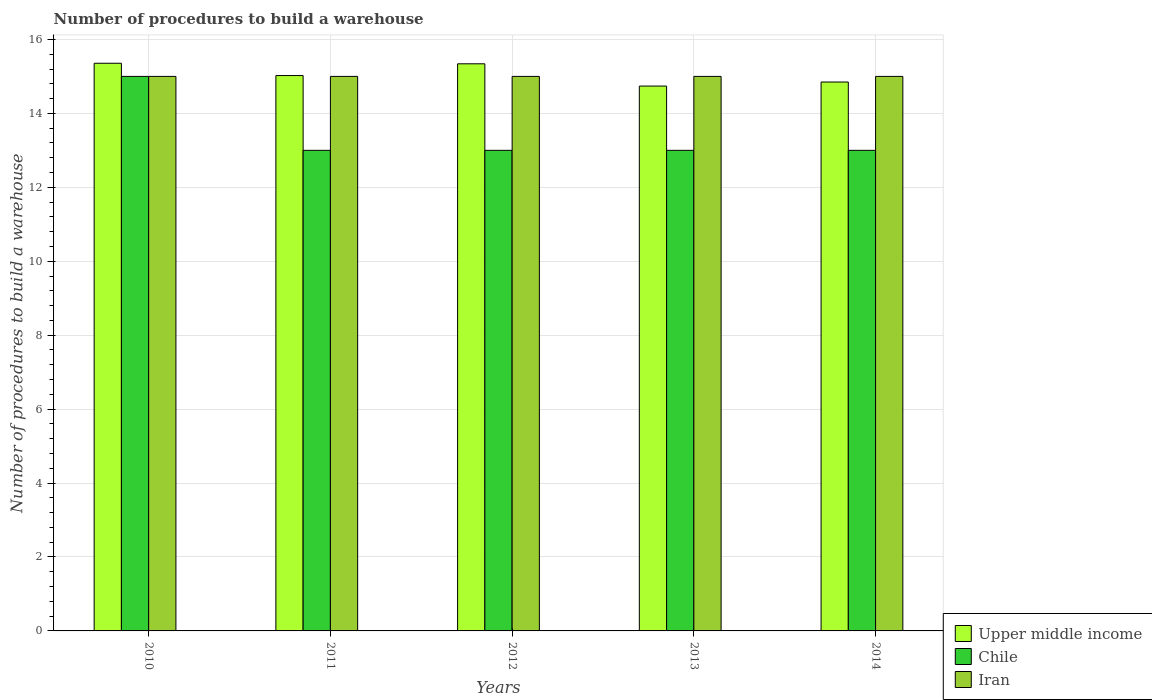How many different coloured bars are there?
Your response must be concise. 3. How many groups of bars are there?
Provide a short and direct response. 5. Are the number of bars per tick equal to the number of legend labels?
Your response must be concise. Yes. Are the number of bars on each tick of the X-axis equal?
Your response must be concise. Yes. How many bars are there on the 1st tick from the left?
Offer a terse response. 3. How many bars are there on the 3rd tick from the right?
Your answer should be compact. 3. In how many cases, is the number of bars for a given year not equal to the number of legend labels?
Provide a short and direct response. 0. What is the number of procedures to build a warehouse in in Iran in 2011?
Provide a succinct answer. 15. Across all years, what is the maximum number of procedures to build a warehouse in in Upper middle income?
Provide a succinct answer. 15.36. Across all years, what is the minimum number of procedures to build a warehouse in in Chile?
Your response must be concise. 13. In which year was the number of procedures to build a warehouse in in Upper middle income minimum?
Provide a succinct answer. 2013. What is the total number of procedures to build a warehouse in in Chile in the graph?
Give a very brief answer. 67. What is the difference between the number of procedures to build a warehouse in in Upper middle income in 2013 and that in 2014?
Offer a terse response. -0.11. What is the difference between the number of procedures to build a warehouse in in Upper middle income in 2014 and the number of procedures to build a warehouse in in Iran in 2012?
Give a very brief answer. -0.15. What is the average number of procedures to build a warehouse in in Upper middle income per year?
Make the answer very short. 15.06. In the year 2014, what is the difference between the number of procedures to build a warehouse in in Upper middle income and number of procedures to build a warehouse in in Iran?
Provide a short and direct response. -0.15. Is the number of procedures to build a warehouse in in Iran in 2010 less than that in 2014?
Your response must be concise. No. What is the difference between the highest and the second highest number of procedures to build a warehouse in in Iran?
Give a very brief answer. 0. What is the difference between the highest and the lowest number of procedures to build a warehouse in in Upper middle income?
Ensure brevity in your answer.  0.62. In how many years, is the number of procedures to build a warehouse in in Iran greater than the average number of procedures to build a warehouse in in Iran taken over all years?
Your answer should be very brief. 0. Is the sum of the number of procedures to build a warehouse in in Upper middle income in 2010 and 2014 greater than the maximum number of procedures to build a warehouse in in Iran across all years?
Offer a terse response. Yes. What does the 1st bar from the left in 2011 represents?
Offer a terse response. Upper middle income. Are all the bars in the graph horizontal?
Ensure brevity in your answer.  No. What is the difference between two consecutive major ticks on the Y-axis?
Keep it short and to the point. 2. Are the values on the major ticks of Y-axis written in scientific E-notation?
Make the answer very short. No. Where does the legend appear in the graph?
Offer a terse response. Bottom right. How many legend labels are there?
Keep it short and to the point. 3. How are the legend labels stacked?
Provide a short and direct response. Vertical. What is the title of the graph?
Your answer should be compact. Number of procedures to build a warehouse. Does "Oman" appear as one of the legend labels in the graph?
Give a very brief answer. No. What is the label or title of the X-axis?
Give a very brief answer. Years. What is the label or title of the Y-axis?
Keep it short and to the point. Number of procedures to build a warehouse. What is the Number of procedures to build a warehouse of Upper middle income in 2010?
Provide a succinct answer. 15.36. What is the Number of procedures to build a warehouse in Upper middle income in 2011?
Provide a short and direct response. 15.02. What is the Number of procedures to build a warehouse in Chile in 2011?
Make the answer very short. 13. What is the Number of procedures to build a warehouse in Upper middle income in 2012?
Provide a short and direct response. 15.34. What is the Number of procedures to build a warehouse of Chile in 2012?
Offer a very short reply. 13. What is the Number of procedures to build a warehouse in Upper middle income in 2013?
Give a very brief answer. 14.74. What is the Number of procedures to build a warehouse of Chile in 2013?
Keep it short and to the point. 13. What is the Number of procedures to build a warehouse in Upper middle income in 2014?
Offer a very short reply. 14.85. What is the Number of procedures to build a warehouse in Iran in 2014?
Ensure brevity in your answer.  15. Across all years, what is the maximum Number of procedures to build a warehouse in Upper middle income?
Your answer should be very brief. 15.36. Across all years, what is the minimum Number of procedures to build a warehouse of Upper middle income?
Give a very brief answer. 14.74. Across all years, what is the minimum Number of procedures to build a warehouse in Chile?
Your answer should be very brief. 13. What is the total Number of procedures to build a warehouse of Upper middle income in the graph?
Provide a short and direct response. 75.31. What is the total Number of procedures to build a warehouse in Chile in the graph?
Your response must be concise. 67. What is the total Number of procedures to build a warehouse in Iran in the graph?
Your answer should be compact. 75. What is the difference between the Number of procedures to build a warehouse in Upper middle income in 2010 and that in 2011?
Offer a very short reply. 0.33. What is the difference between the Number of procedures to build a warehouse in Chile in 2010 and that in 2011?
Ensure brevity in your answer.  2. What is the difference between the Number of procedures to build a warehouse of Upper middle income in 2010 and that in 2012?
Offer a very short reply. 0.01. What is the difference between the Number of procedures to build a warehouse in Chile in 2010 and that in 2012?
Provide a succinct answer. 2. What is the difference between the Number of procedures to build a warehouse of Upper middle income in 2010 and that in 2013?
Offer a terse response. 0.62. What is the difference between the Number of procedures to build a warehouse of Iran in 2010 and that in 2013?
Offer a very short reply. 0. What is the difference between the Number of procedures to build a warehouse of Upper middle income in 2010 and that in 2014?
Offer a terse response. 0.51. What is the difference between the Number of procedures to build a warehouse of Chile in 2010 and that in 2014?
Provide a short and direct response. 2. What is the difference between the Number of procedures to build a warehouse of Iran in 2010 and that in 2014?
Keep it short and to the point. 0. What is the difference between the Number of procedures to build a warehouse of Upper middle income in 2011 and that in 2012?
Your answer should be very brief. -0.32. What is the difference between the Number of procedures to build a warehouse of Upper middle income in 2011 and that in 2013?
Your answer should be very brief. 0.28. What is the difference between the Number of procedures to build a warehouse in Chile in 2011 and that in 2013?
Your response must be concise. 0. What is the difference between the Number of procedures to build a warehouse in Upper middle income in 2011 and that in 2014?
Your answer should be very brief. 0.17. What is the difference between the Number of procedures to build a warehouse in Iran in 2011 and that in 2014?
Provide a short and direct response. 0. What is the difference between the Number of procedures to build a warehouse in Upper middle income in 2012 and that in 2013?
Your response must be concise. 0.6. What is the difference between the Number of procedures to build a warehouse in Upper middle income in 2012 and that in 2014?
Your answer should be compact. 0.49. What is the difference between the Number of procedures to build a warehouse of Upper middle income in 2013 and that in 2014?
Provide a short and direct response. -0.11. What is the difference between the Number of procedures to build a warehouse in Iran in 2013 and that in 2014?
Make the answer very short. 0. What is the difference between the Number of procedures to build a warehouse of Upper middle income in 2010 and the Number of procedures to build a warehouse of Chile in 2011?
Your answer should be very brief. 2.36. What is the difference between the Number of procedures to build a warehouse in Upper middle income in 2010 and the Number of procedures to build a warehouse in Iran in 2011?
Make the answer very short. 0.36. What is the difference between the Number of procedures to build a warehouse of Upper middle income in 2010 and the Number of procedures to build a warehouse of Chile in 2012?
Provide a succinct answer. 2.36. What is the difference between the Number of procedures to build a warehouse in Upper middle income in 2010 and the Number of procedures to build a warehouse in Iran in 2012?
Offer a very short reply. 0.36. What is the difference between the Number of procedures to build a warehouse in Chile in 2010 and the Number of procedures to build a warehouse in Iran in 2012?
Provide a short and direct response. 0. What is the difference between the Number of procedures to build a warehouse in Upper middle income in 2010 and the Number of procedures to build a warehouse in Chile in 2013?
Your response must be concise. 2.36. What is the difference between the Number of procedures to build a warehouse of Upper middle income in 2010 and the Number of procedures to build a warehouse of Iran in 2013?
Give a very brief answer. 0.36. What is the difference between the Number of procedures to build a warehouse in Chile in 2010 and the Number of procedures to build a warehouse in Iran in 2013?
Offer a very short reply. 0. What is the difference between the Number of procedures to build a warehouse in Upper middle income in 2010 and the Number of procedures to build a warehouse in Chile in 2014?
Give a very brief answer. 2.36. What is the difference between the Number of procedures to build a warehouse of Upper middle income in 2010 and the Number of procedures to build a warehouse of Iran in 2014?
Give a very brief answer. 0.36. What is the difference between the Number of procedures to build a warehouse in Chile in 2010 and the Number of procedures to build a warehouse in Iran in 2014?
Make the answer very short. 0. What is the difference between the Number of procedures to build a warehouse in Upper middle income in 2011 and the Number of procedures to build a warehouse in Chile in 2012?
Offer a terse response. 2.02. What is the difference between the Number of procedures to build a warehouse in Upper middle income in 2011 and the Number of procedures to build a warehouse in Iran in 2012?
Keep it short and to the point. 0.02. What is the difference between the Number of procedures to build a warehouse of Upper middle income in 2011 and the Number of procedures to build a warehouse of Chile in 2013?
Offer a terse response. 2.02. What is the difference between the Number of procedures to build a warehouse of Upper middle income in 2011 and the Number of procedures to build a warehouse of Iran in 2013?
Your response must be concise. 0.02. What is the difference between the Number of procedures to build a warehouse of Upper middle income in 2011 and the Number of procedures to build a warehouse of Chile in 2014?
Ensure brevity in your answer.  2.02. What is the difference between the Number of procedures to build a warehouse in Upper middle income in 2011 and the Number of procedures to build a warehouse in Iran in 2014?
Your answer should be compact. 0.02. What is the difference between the Number of procedures to build a warehouse in Upper middle income in 2012 and the Number of procedures to build a warehouse in Chile in 2013?
Offer a very short reply. 2.34. What is the difference between the Number of procedures to build a warehouse of Upper middle income in 2012 and the Number of procedures to build a warehouse of Iran in 2013?
Give a very brief answer. 0.34. What is the difference between the Number of procedures to build a warehouse of Chile in 2012 and the Number of procedures to build a warehouse of Iran in 2013?
Provide a succinct answer. -2. What is the difference between the Number of procedures to build a warehouse of Upper middle income in 2012 and the Number of procedures to build a warehouse of Chile in 2014?
Give a very brief answer. 2.34. What is the difference between the Number of procedures to build a warehouse in Upper middle income in 2012 and the Number of procedures to build a warehouse in Iran in 2014?
Offer a very short reply. 0.34. What is the difference between the Number of procedures to build a warehouse in Upper middle income in 2013 and the Number of procedures to build a warehouse in Chile in 2014?
Provide a succinct answer. 1.74. What is the difference between the Number of procedures to build a warehouse in Upper middle income in 2013 and the Number of procedures to build a warehouse in Iran in 2014?
Ensure brevity in your answer.  -0.26. What is the average Number of procedures to build a warehouse of Upper middle income per year?
Give a very brief answer. 15.06. In the year 2010, what is the difference between the Number of procedures to build a warehouse in Upper middle income and Number of procedures to build a warehouse in Chile?
Keep it short and to the point. 0.36. In the year 2010, what is the difference between the Number of procedures to build a warehouse of Upper middle income and Number of procedures to build a warehouse of Iran?
Your answer should be very brief. 0.36. In the year 2010, what is the difference between the Number of procedures to build a warehouse of Chile and Number of procedures to build a warehouse of Iran?
Offer a very short reply. 0. In the year 2011, what is the difference between the Number of procedures to build a warehouse of Upper middle income and Number of procedures to build a warehouse of Chile?
Give a very brief answer. 2.02. In the year 2011, what is the difference between the Number of procedures to build a warehouse of Upper middle income and Number of procedures to build a warehouse of Iran?
Provide a short and direct response. 0.02. In the year 2012, what is the difference between the Number of procedures to build a warehouse in Upper middle income and Number of procedures to build a warehouse in Chile?
Provide a short and direct response. 2.34. In the year 2012, what is the difference between the Number of procedures to build a warehouse in Upper middle income and Number of procedures to build a warehouse in Iran?
Give a very brief answer. 0.34. In the year 2012, what is the difference between the Number of procedures to build a warehouse of Chile and Number of procedures to build a warehouse of Iran?
Your answer should be compact. -2. In the year 2013, what is the difference between the Number of procedures to build a warehouse in Upper middle income and Number of procedures to build a warehouse in Chile?
Provide a succinct answer. 1.74. In the year 2013, what is the difference between the Number of procedures to build a warehouse in Upper middle income and Number of procedures to build a warehouse in Iran?
Offer a terse response. -0.26. In the year 2013, what is the difference between the Number of procedures to build a warehouse in Chile and Number of procedures to build a warehouse in Iran?
Provide a succinct answer. -2. In the year 2014, what is the difference between the Number of procedures to build a warehouse in Upper middle income and Number of procedures to build a warehouse in Chile?
Provide a succinct answer. 1.85. In the year 2014, what is the difference between the Number of procedures to build a warehouse in Upper middle income and Number of procedures to build a warehouse in Iran?
Provide a short and direct response. -0.15. What is the ratio of the Number of procedures to build a warehouse in Upper middle income in 2010 to that in 2011?
Your answer should be compact. 1.02. What is the ratio of the Number of procedures to build a warehouse of Chile in 2010 to that in 2011?
Keep it short and to the point. 1.15. What is the ratio of the Number of procedures to build a warehouse of Chile in 2010 to that in 2012?
Keep it short and to the point. 1.15. What is the ratio of the Number of procedures to build a warehouse of Upper middle income in 2010 to that in 2013?
Offer a terse response. 1.04. What is the ratio of the Number of procedures to build a warehouse of Chile in 2010 to that in 2013?
Give a very brief answer. 1.15. What is the ratio of the Number of procedures to build a warehouse of Upper middle income in 2010 to that in 2014?
Ensure brevity in your answer.  1.03. What is the ratio of the Number of procedures to build a warehouse of Chile in 2010 to that in 2014?
Your answer should be compact. 1.15. What is the ratio of the Number of procedures to build a warehouse of Upper middle income in 2011 to that in 2012?
Ensure brevity in your answer.  0.98. What is the ratio of the Number of procedures to build a warehouse in Upper middle income in 2011 to that in 2013?
Keep it short and to the point. 1.02. What is the ratio of the Number of procedures to build a warehouse in Iran in 2011 to that in 2013?
Give a very brief answer. 1. What is the ratio of the Number of procedures to build a warehouse in Upper middle income in 2011 to that in 2014?
Provide a succinct answer. 1.01. What is the ratio of the Number of procedures to build a warehouse in Iran in 2011 to that in 2014?
Provide a short and direct response. 1. What is the ratio of the Number of procedures to build a warehouse of Upper middle income in 2012 to that in 2013?
Offer a terse response. 1.04. What is the ratio of the Number of procedures to build a warehouse of Iran in 2012 to that in 2013?
Give a very brief answer. 1. What is the ratio of the Number of procedures to build a warehouse in Upper middle income in 2012 to that in 2014?
Provide a short and direct response. 1.03. What is the ratio of the Number of procedures to build a warehouse in Upper middle income in 2013 to that in 2014?
Offer a very short reply. 0.99. What is the ratio of the Number of procedures to build a warehouse of Iran in 2013 to that in 2014?
Provide a succinct answer. 1. What is the difference between the highest and the second highest Number of procedures to build a warehouse in Upper middle income?
Provide a succinct answer. 0.01. What is the difference between the highest and the second highest Number of procedures to build a warehouse of Chile?
Make the answer very short. 2. What is the difference between the highest and the lowest Number of procedures to build a warehouse in Upper middle income?
Offer a terse response. 0.62. What is the difference between the highest and the lowest Number of procedures to build a warehouse in Chile?
Keep it short and to the point. 2. What is the difference between the highest and the lowest Number of procedures to build a warehouse in Iran?
Keep it short and to the point. 0. 